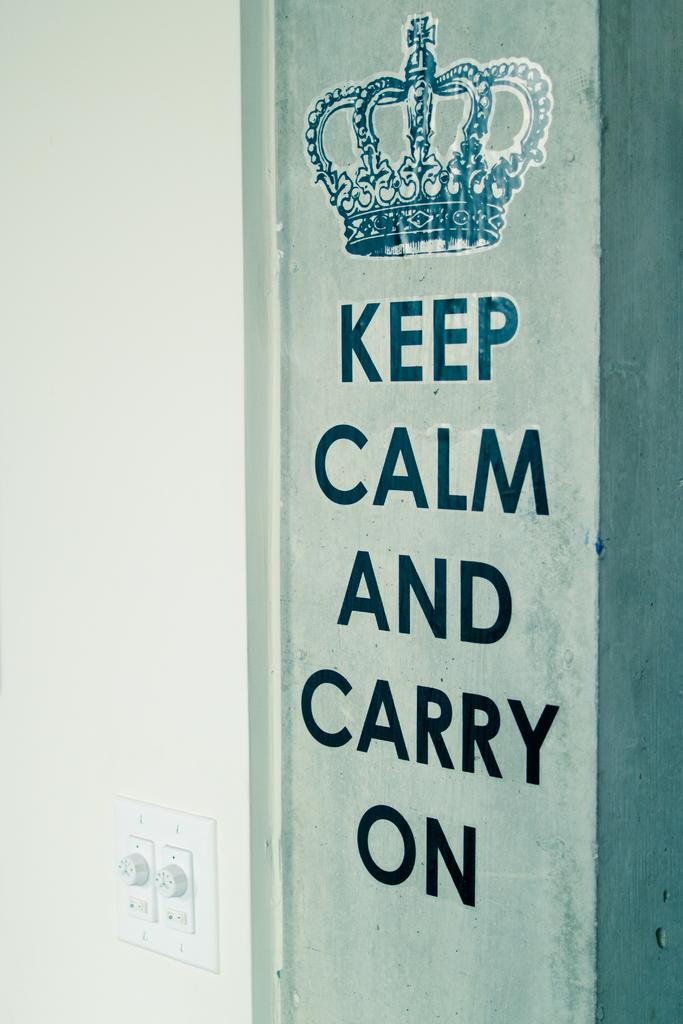What objects can be seen in the image that are used to control electricity or lighting? There are switches in the image that are used to control electricity or lighting. What can be found on the wall in the image that provides information or instructions? There is text on the wall in the image that provides information or instructions. What type of beef is being prepared in the image? There is no beef present in the image; it only features switches and text on the wall. How many police officers are visible in the image? There are no police officers present in the image. 